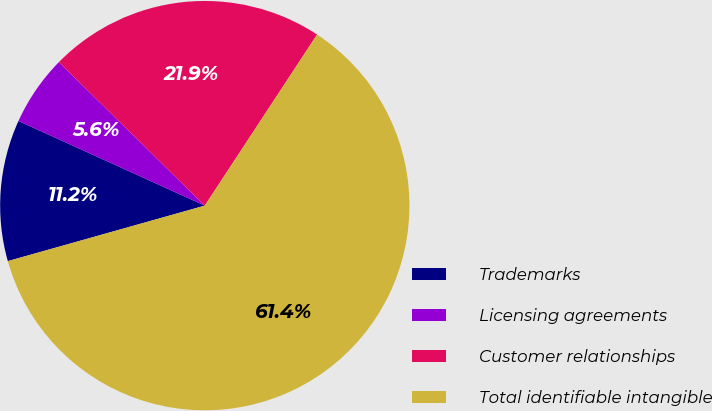<chart> <loc_0><loc_0><loc_500><loc_500><pie_chart><fcel>Trademarks<fcel>Licensing agreements<fcel>Customer relationships<fcel>Total identifiable intangible<nl><fcel>11.16%<fcel>5.58%<fcel>21.88%<fcel>61.39%<nl></chart> 